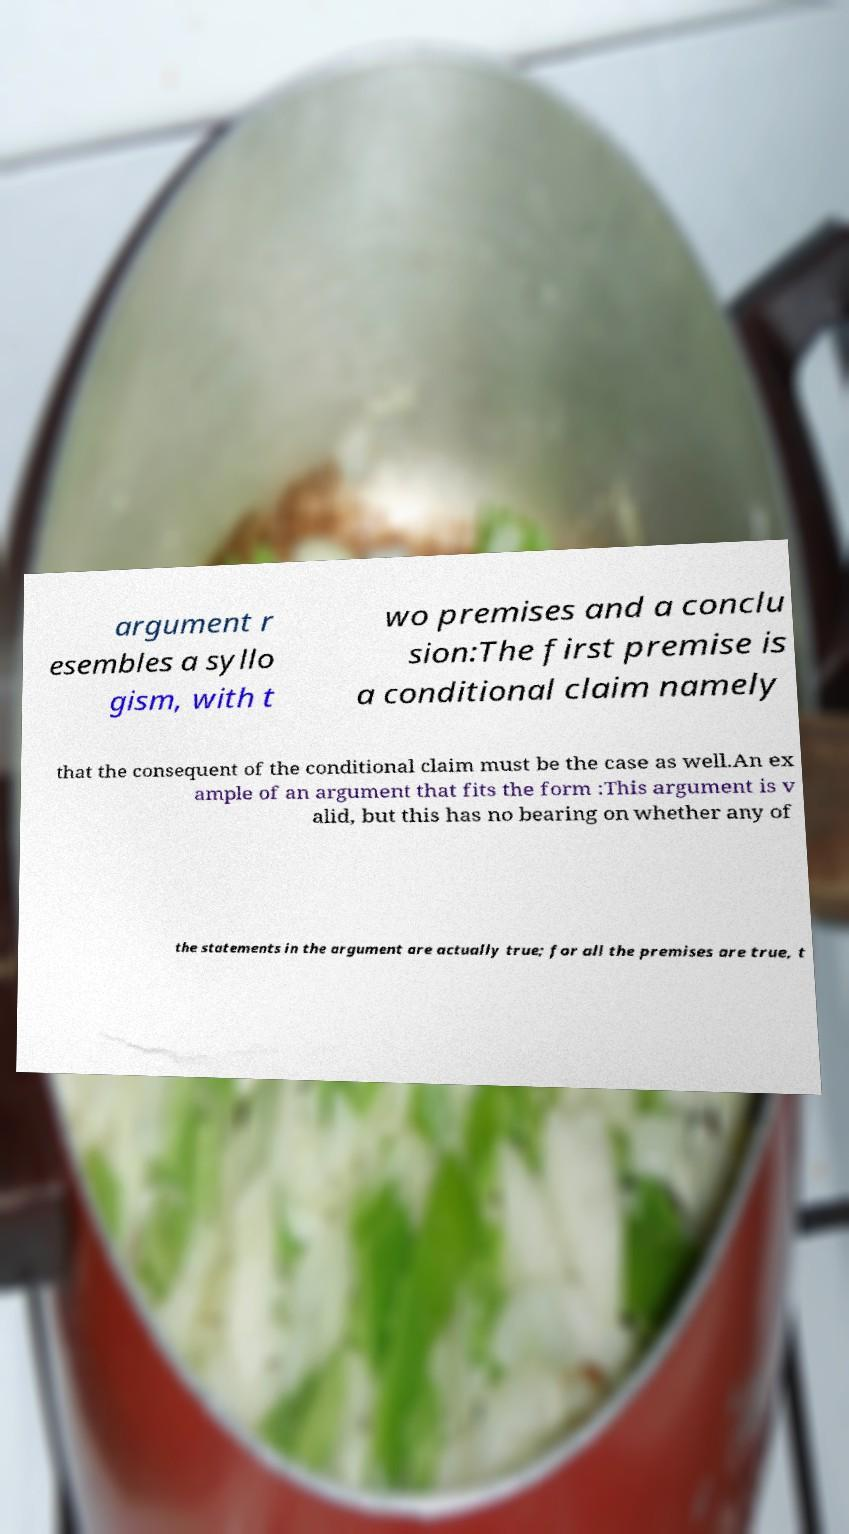Could you extract and type out the text from this image? argument r esembles a syllo gism, with t wo premises and a conclu sion:The first premise is a conditional claim namely that the consequent of the conditional claim must be the case as well.An ex ample of an argument that fits the form :This argument is v alid, but this has no bearing on whether any of the statements in the argument are actually true; for all the premises are true, t 